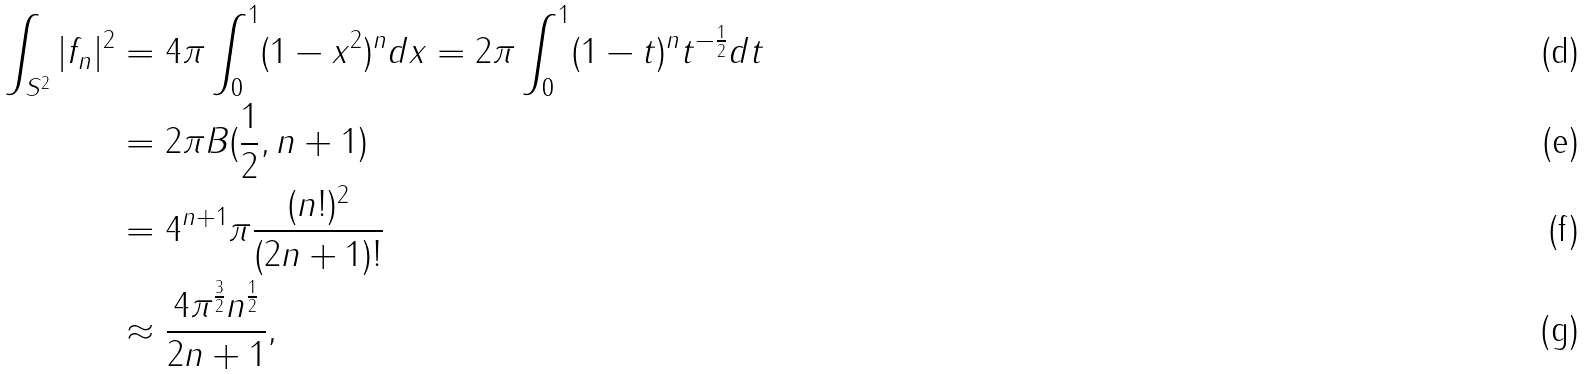<formula> <loc_0><loc_0><loc_500><loc_500>\int _ { S ^ { 2 } } | f _ { n } | ^ { 2 } & = 4 \pi \int _ { 0 } ^ { 1 } ( 1 - x ^ { 2 } ) ^ { n } d x = 2 \pi \int _ { 0 } ^ { 1 } ( 1 - t ) ^ { n } t ^ { - \frac { 1 } { 2 } } d t \\ & = 2 \pi B ( \frac { 1 } { 2 } , n + 1 ) \\ & = 4 ^ { n + 1 } \pi \frac { ( n ! ) ^ { 2 } } { ( 2 n + 1 ) ! } \\ & \approx \frac { 4 \pi ^ { \frac { 3 } { 2 } } n ^ { \frac { 1 } { 2 } } } { 2 n + 1 } ,</formula> 